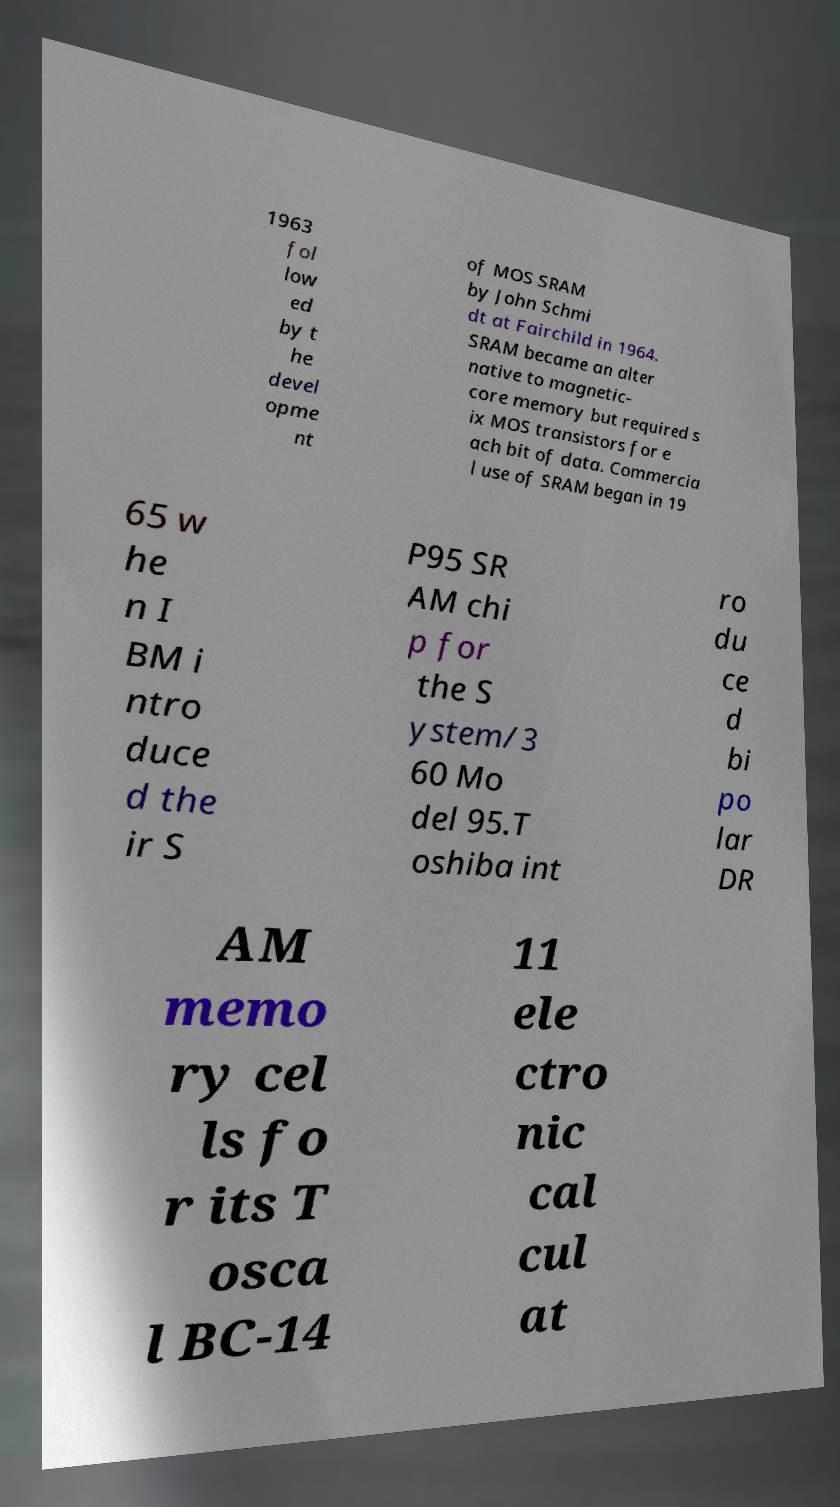There's text embedded in this image that I need extracted. Can you transcribe it verbatim? 1963 fol low ed by t he devel opme nt of MOS SRAM by John Schmi dt at Fairchild in 1964. SRAM became an alter native to magnetic- core memory but required s ix MOS transistors for e ach bit of data. Commercia l use of SRAM began in 19 65 w he n I BM i ntro duce d the ir S P95 SR AM chi p for the S ystem/3 60 Mo del 95.T oshiba int ro du ce d bi po lar DR AM memo ry cel ls fo r its T osca l BC-14 11 ele ctro nic cal cul at 